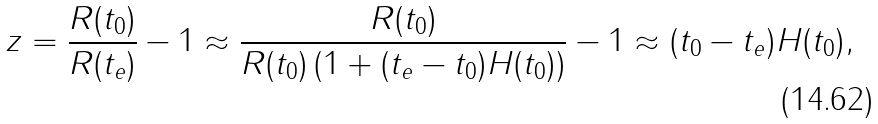<formula> <loc_0><loc_0><loc_500><loc_500>z = { \frac { R ( t _ { 0 } ) } { R ( t _ { e } ) } } - 1 \approx { \frac { R ( t _ { 0 } ) } { R ( t _ { 0 } ) \left ( 1 + ( t _ { e } - t _ { 0 } ) H ( t _ { 0 } ) \right ) } } - 1 \approx ( t _ { 0 } - t _ { e } ) H ( t _ { 0 } ) ,</formula> 